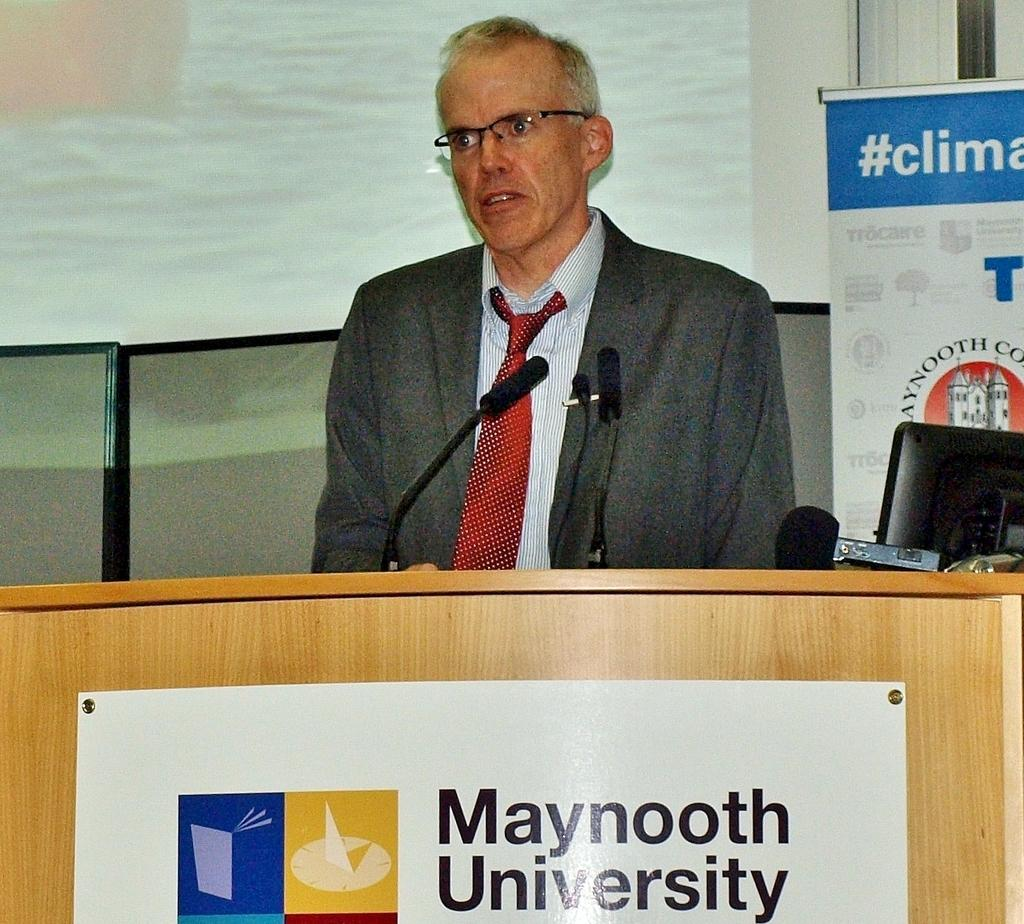<image>
Provide a brief description of the given image. A man behind a lectern with Maynooth University on the front of it. 